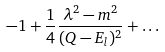<formula> <loc_0><loc_0><loc_500><loc_500>- 1 + \frac { 1 } { 4 } \frac { \lambda ^ { 2 } - m ^ { 2 } } { ( Q - E _ { l } ) ^ { 2 } } + \dots</formula> 